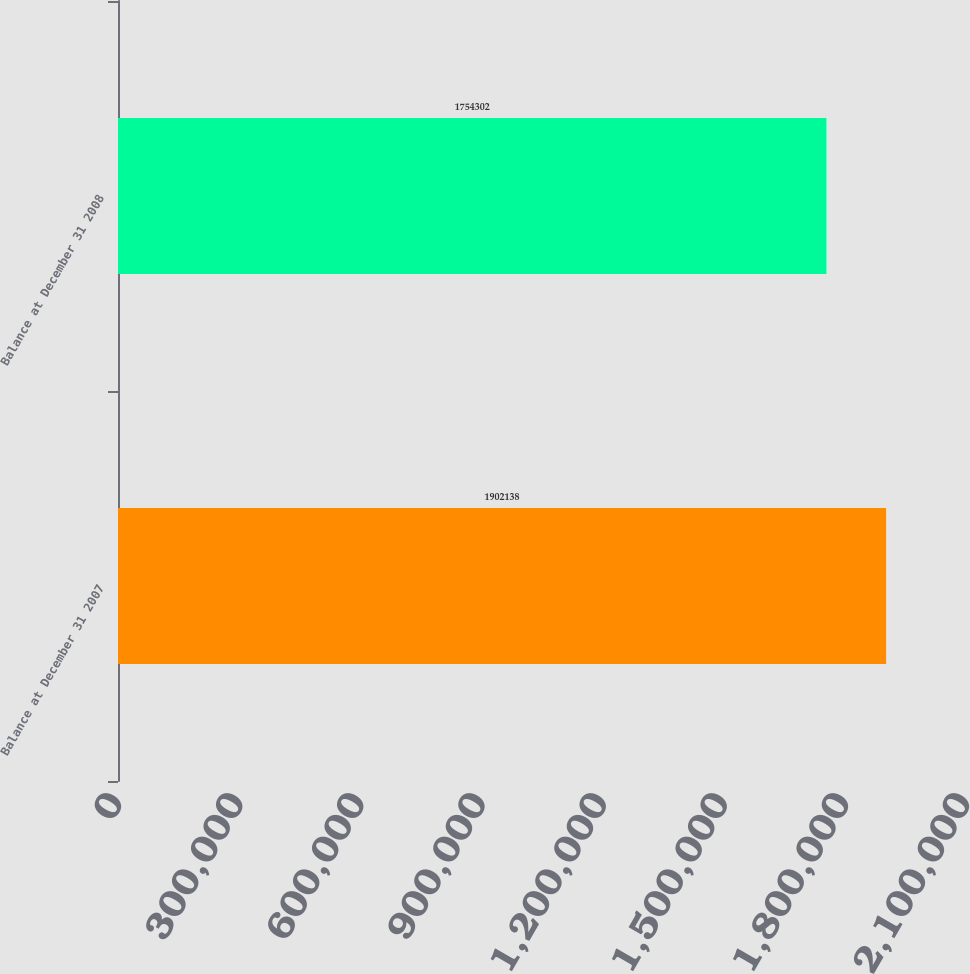Convert chart to OTSL. <chart><loc_0><loc_0><loc_500><loc_500><bar_chart><fcel>Balance at December 31 2007<fcel>Balance at December 31 2008<nl><fcel>1.90214e+06<fcel>1.7543e+06<nl></chart> 